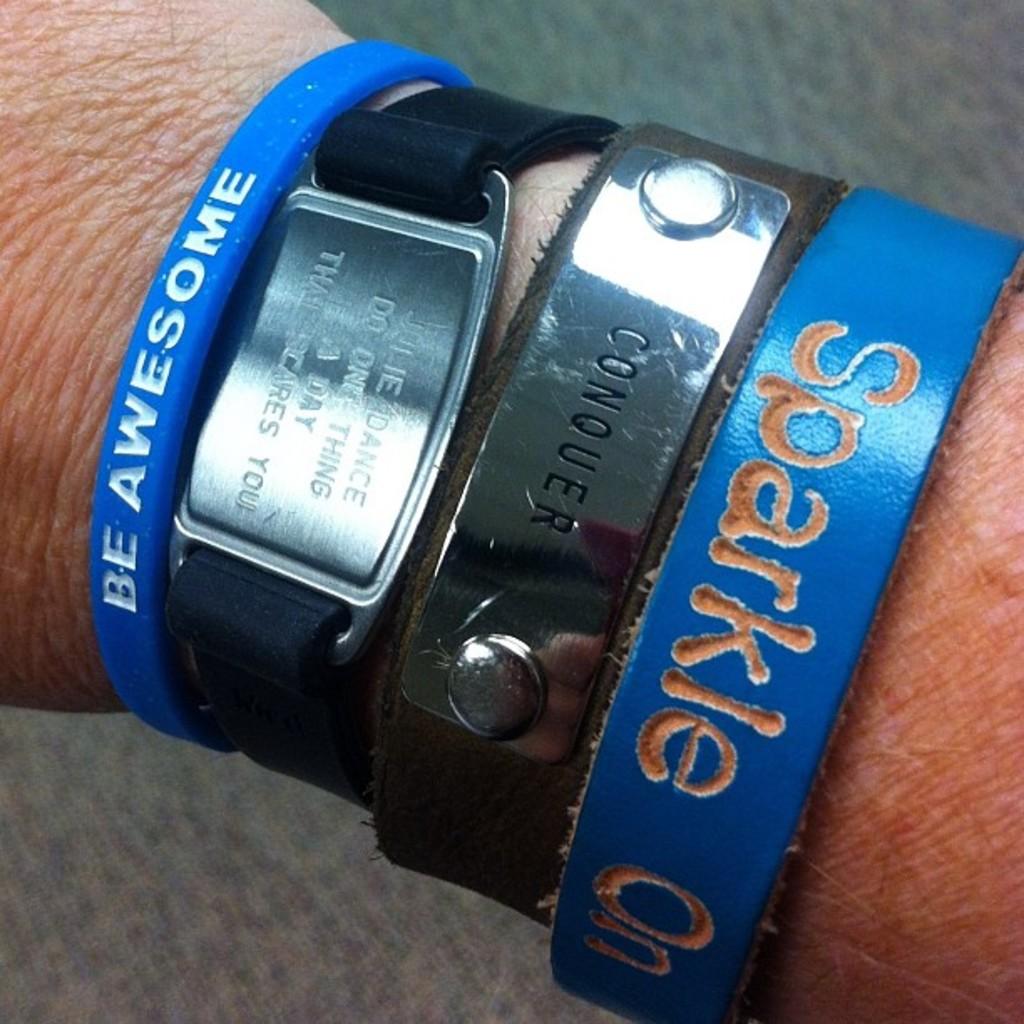How many wrist bands can you see?
Keep it short and to the point. Answering does not require reading text in the image. What does the big silver buckle say?
Provide a short and direct response. Conquer. 